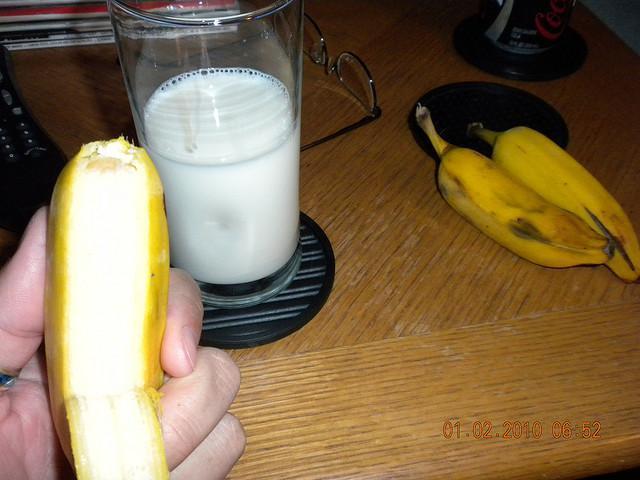How many bananas can you see?
Give a very brief answer. 3. 